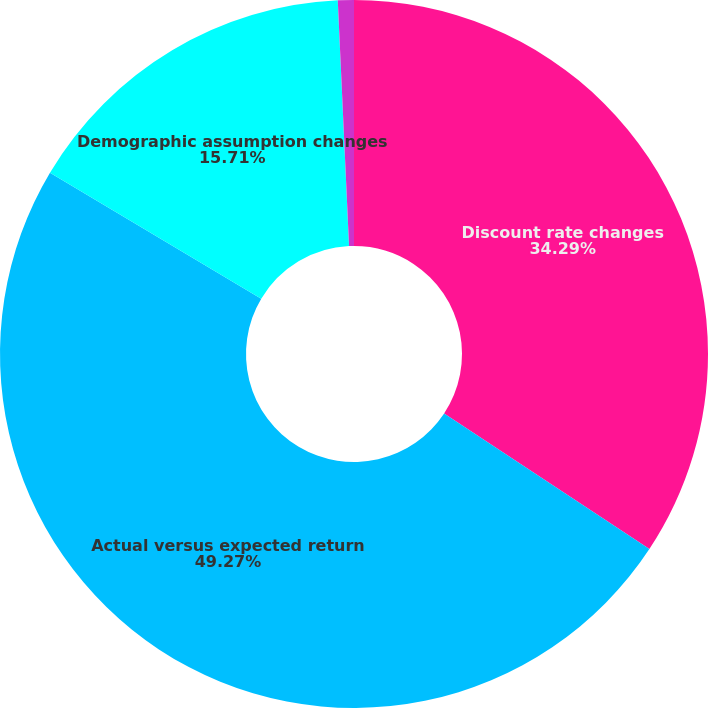Convert chart. <chart><loc_0><loc_0><loc_500><loc_500><pie_chart><fcel>Discount rate changes<fcel>Actual versus expected return<fcel>Demographic assumption changes<fcel>Total mark-to-market loss<nl><fcel>34.29%<fcel>49.27%<fcel>15.71%<fcel>0.73%<nl></chart> 